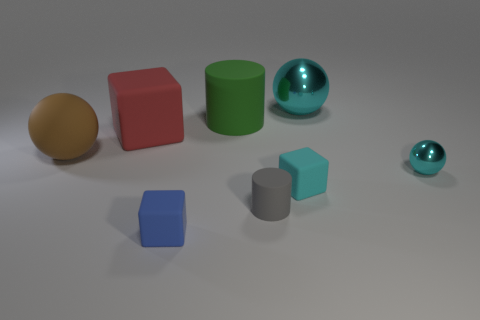There is a small thing that is the same color as the small sphere; what is its material?
Your response must be concise. Rubber. What is the size of the shiny object that is the same color as the small ball?
Offer a very short reply. Large. Are there any matte cubes of the same size as the gray rubber thing?
Ensure brevity in your answer.  Yes. Does the large cyan thing have the same material as the brown object in front of the green object?
Your response must be concise. No. Are there more large red blocks than small gray cubes?
Provide a succinct answer. Yes. What number of blocks are large red things or big green rubber objects?
Ensure brevity in your answer.  1. What is the color of the large matte cylinder?
Give a very brief answer. Green. There is a cyan metallic object that is behind the large block; is its size the same as the shiny ball in front of the big matte cube?
Provide a short and direct response. No. Is the number of small gray things less than the number of red shiny spheres?
Provide a short and direct response. No. How many cyan matte blocks are right of the blue block?
Your answer should be very brief. 1. 